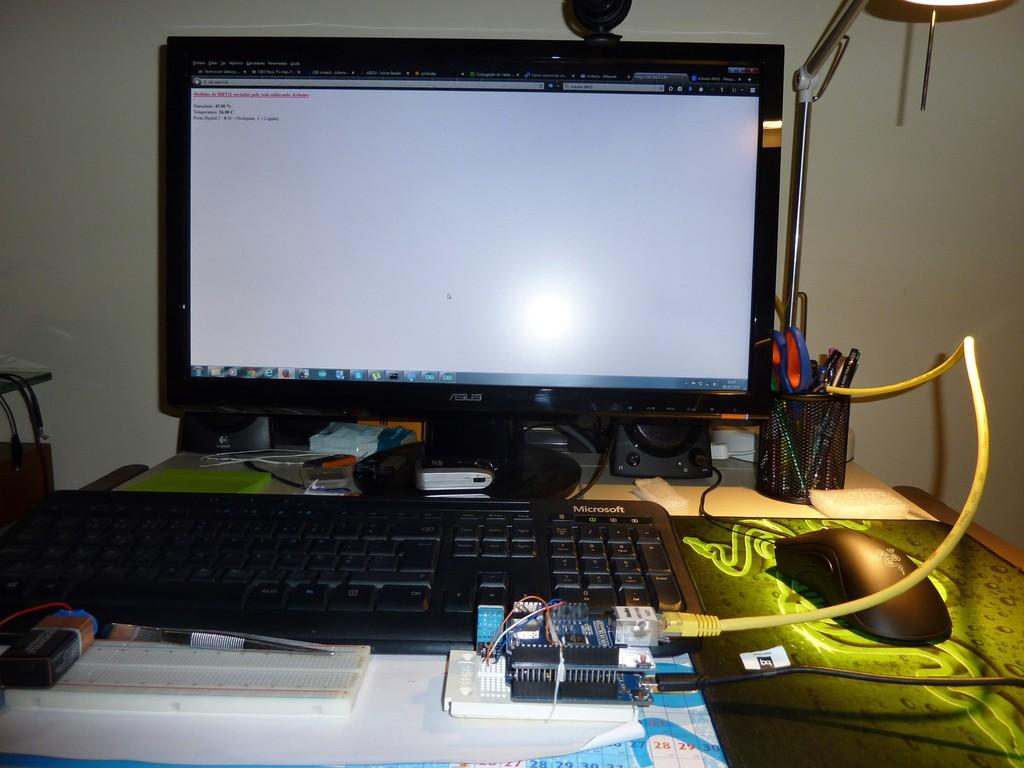What is the main object in the center of the image? There is a table in the center of the image. What electronic device is on the table? A monitor is present on the table. What input device is on the table? A keyboard and a mouse are on the table. What non-electronic items are on the table? There is a book, scissors, and a pen on the table. What can be seen in the background of the image? There is a wall in the background of the image. What type of teeth can be seen on the monitor in the image? There are no teeth visible on the monitor or any other part of the image. 